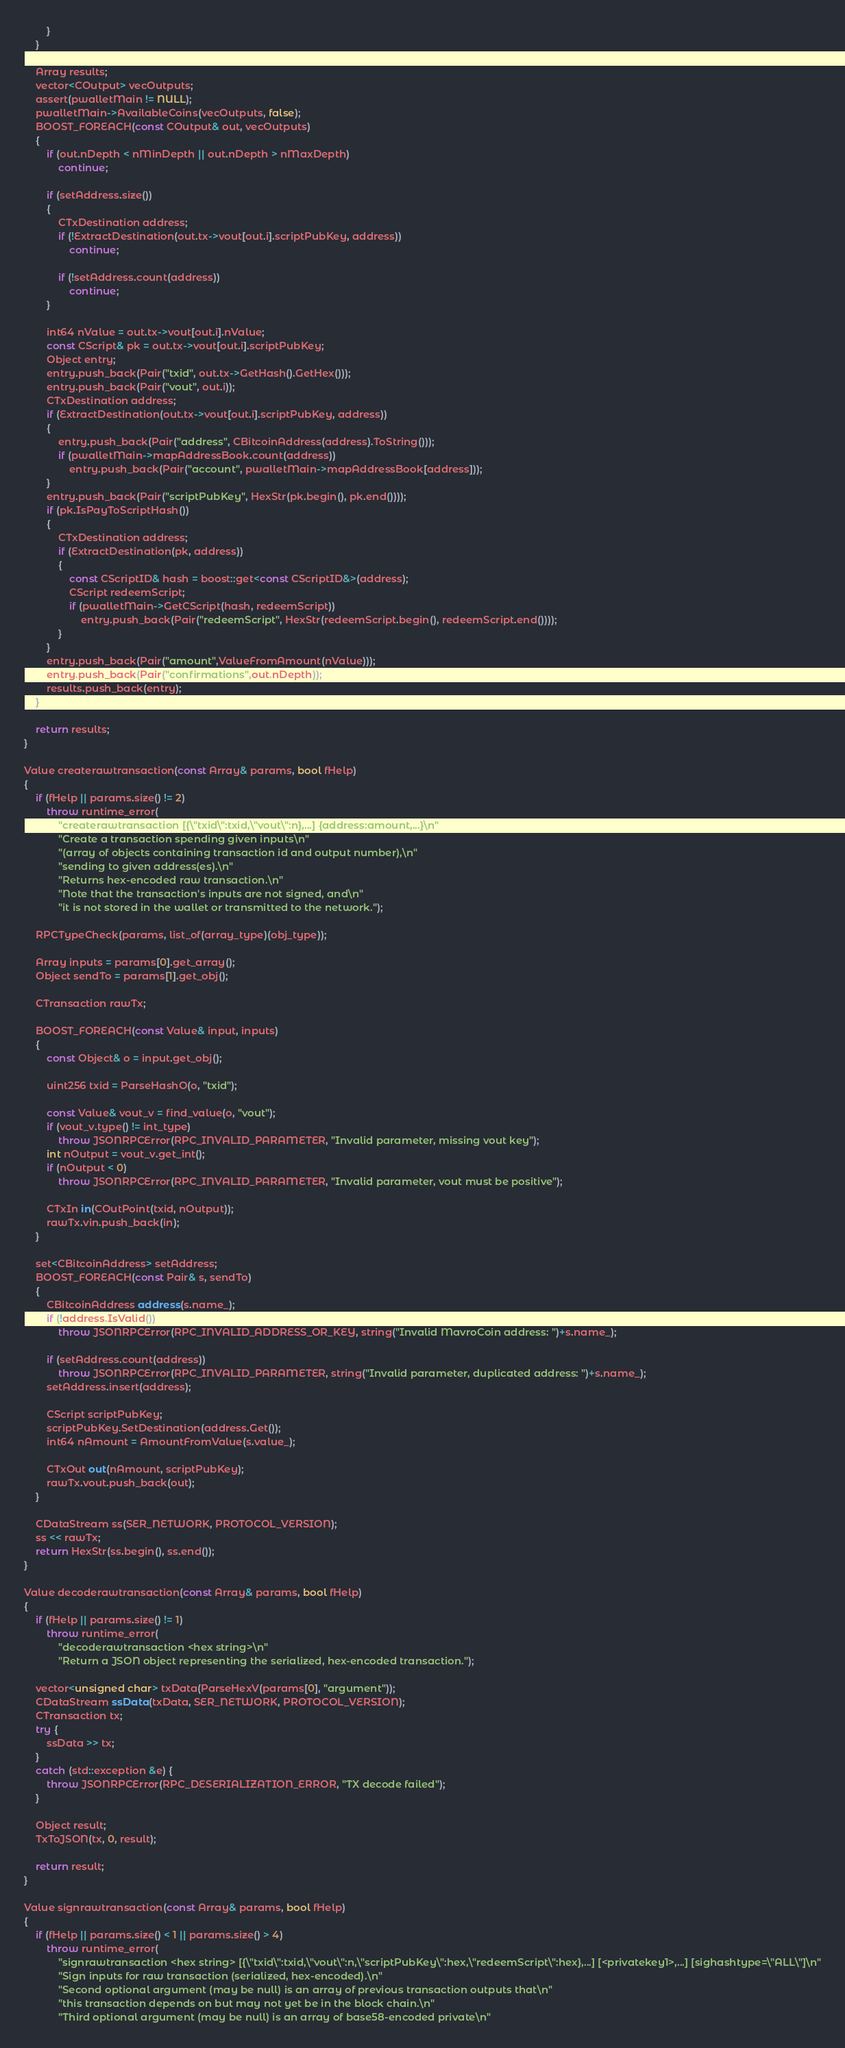<code> <loc_0><loc_0><loc_500><loc_500><_C++_>        }
    }

    Array results;
    vector<COutput> vecOutputs;
    assert(pwalletMain != NULL);
    pwalletMain->AvailableCoins(vecOutputs, false);
    BOOST_FOREACH(const COutput& out, vecOutputs)
    {
        if (out.nDepth < nMinDepth || out.nDepth > nMaxDepth)
            continue;

        if (setAddress.size())
        {
            CTxDestination address;
            if (!ExtractDestination(out.tx->vout[out.i].scriptPubKey, address))
                continue;

            if (!setAddress.count(address))
                continue;
        }

        int64 nValue = out.tx->vout[out.i].nValue;
        const CScript& pk = out.tx->vout[out.i].scriptPubKey;
        Object entry;
        entry.push_back(Pair("txid", out.tx->GetHash().GetHex()));
        entry.push_back(Pair("vout", out.i));
        CTxDestination address;
        if (ExtractDestination(out.tx->vout[out.i].scriptPubKey, address))
        {
            entry.push_back(Pair("address", CBitcoinAddress(address).ToString()));
            if (pwalletMain->mapAddressBook.count(address))
                entry.push_back(Pair("account", pwalletMain->mapAddressBook[address]));
        }
        entry.push_back(Pair("scriptPubKey", HexStr(pk.begin(), pk.end())));
        if (pk.IsPayToScriptHash())
        {
            CTxDestination address;
            if (ExtractDestination(pk, address))
            {
                const CScriptID& hash = boost::get<const CScriptID&>(address);
                CScript redeemScript;
                if (pwalletMain->GetCScript(hash, redeemScript))
                    entry.push_back(Pair("redeemScript", HexStr(redeemScript.begin(), redeemScript.end())));
            }
        }
        entry.push_back(Pair("amount",ValueFromAmount(nValue)));
        entry.push_back(Pair("confirmations",out.nDepth));
        results.push_back(entry);
    }

    return results;
}

Value createrawtransaction(const Array& params, bool fHelp)
{
    if (fHelp || params.size() != 2)
        throw runtime_error(
            "createrawtransaction [{\"txid\":txid,\"vout\":n},...] {address:amount,...}\n"
            "Create a transaction spending given inputs\n"
            "(array of objects containing transaction id and output number),\n"
            "sending to given address(es).\n"
            "Returns hex-encoded raw transaction.\n"
            "Note that the transaction's inputs are not signed, and\n"
            "it is not stored in the wallet or transmitted to the network.");

    RPCTypeCheck(params, list_of(array_type)(obj_type));

    Array inputs = params[0].get_array();
    Object sendTo = params[1].get_obj();

    CTransaction rawTx;

    BOOST_FOREACH(const Value& input, inputs)
    {
        const Object& o = input.get_obj();

        uint256 txid = ParseHashO(o, "txid");

        const Value& vout_v = find_value(o, "vout");
        if (vout_v.type() != int_type)
            throw JSONRPCError(RPC_INVALID_PARAMETER, "Invalid parameter, missing vout key");
        int nOutput = vout_v.get_int();
        if (nOutput < 0)
            throw JSONRPCError(RPC_INVALID_PARAMETER, "Invalid parameter, vout must be positive");

        CTxIn in(COutPoint(txid, nOutput));
        rawTx.vin.push_back(in);
    }

    set<CBitcoinAddress> setAddress;
    BOOST_FOREACH(const Pair& s, sendTo)
    {
        CBitcoinAddress address(s.name_);
        if (!address.IsValid())
            throw JSONRPCError(RPC_INVALID_ADDRESS_OR_KEY, string("Invalid MavroCoin address: ")+s.name_);

        if (setAddress.count(address))
            throw JSONRPCError(RPC_INVALID_PARAMETER, string("Invalid parameter, duplicated address: ")+s.name_);
        setAddress.insert(address);

        CScript scriptPubKey;
        scriptPubKey.SetDestination(address.Get());
        int64 nAmount = AmountFromValue(s.value_);

        CTxOut out(nAmount, scriptPubKey);
        rawTx.vout.push_back(out);
    }

    CDataStream ss(SER_NETWORK, PROTOCOL_VERSION);
    ss << rawTx;
    return HexStr(ss.begin(), ss.end());
}

Value decoderawtransaction(const Array& params, bool fHelp)
{
    if (fHelp || params.size() != 1)
        throw runtime_error(
            "decoderawtransaction <hex string>\n"
            "Return a JSON object representing the serialized, hex-encoded transaction.");

    vector<unsigned char> txData(ParseHexV(params[0], "argument"));
    CDataStream ssData(txData, SER_NETWORK, PROTOCOL_VERSION);
    CTransaction tx;
    try {
        ssData >> tx;
    }
    catch (std::exception &e) {
        throw JSONRPCError(RPC_DESERIALIZATION_ERROR, "TX decode failed");
    }

    Object result;
    TxToJSON(tx, 0, result);

    return result;
}

Value signrawtransaction(const Array& params, bool fHelp)
{
    if (fHelp || params.size() < 1 || params.size() > 4)
        throw runtime_error(
            "signrawtransaction <hex string> [{\"txid\":txid,\"vout\":n,\"scriptPubKey\":hex,\"redeemScript\":hex},...] [<privatekey1>,...] [sighashtype=\"ALL\"]\n"
            "Sign inputs for raw transaction (serialized, hex-encoded).\n"
            "Second optional argument (may be null) is an array of previous transaction outputs that\n"
            "this transaction depends on but may not yet be in the block chain.\n"
            "Third optional argument (may be null) is an array of base58-encoded private\n"</code> 